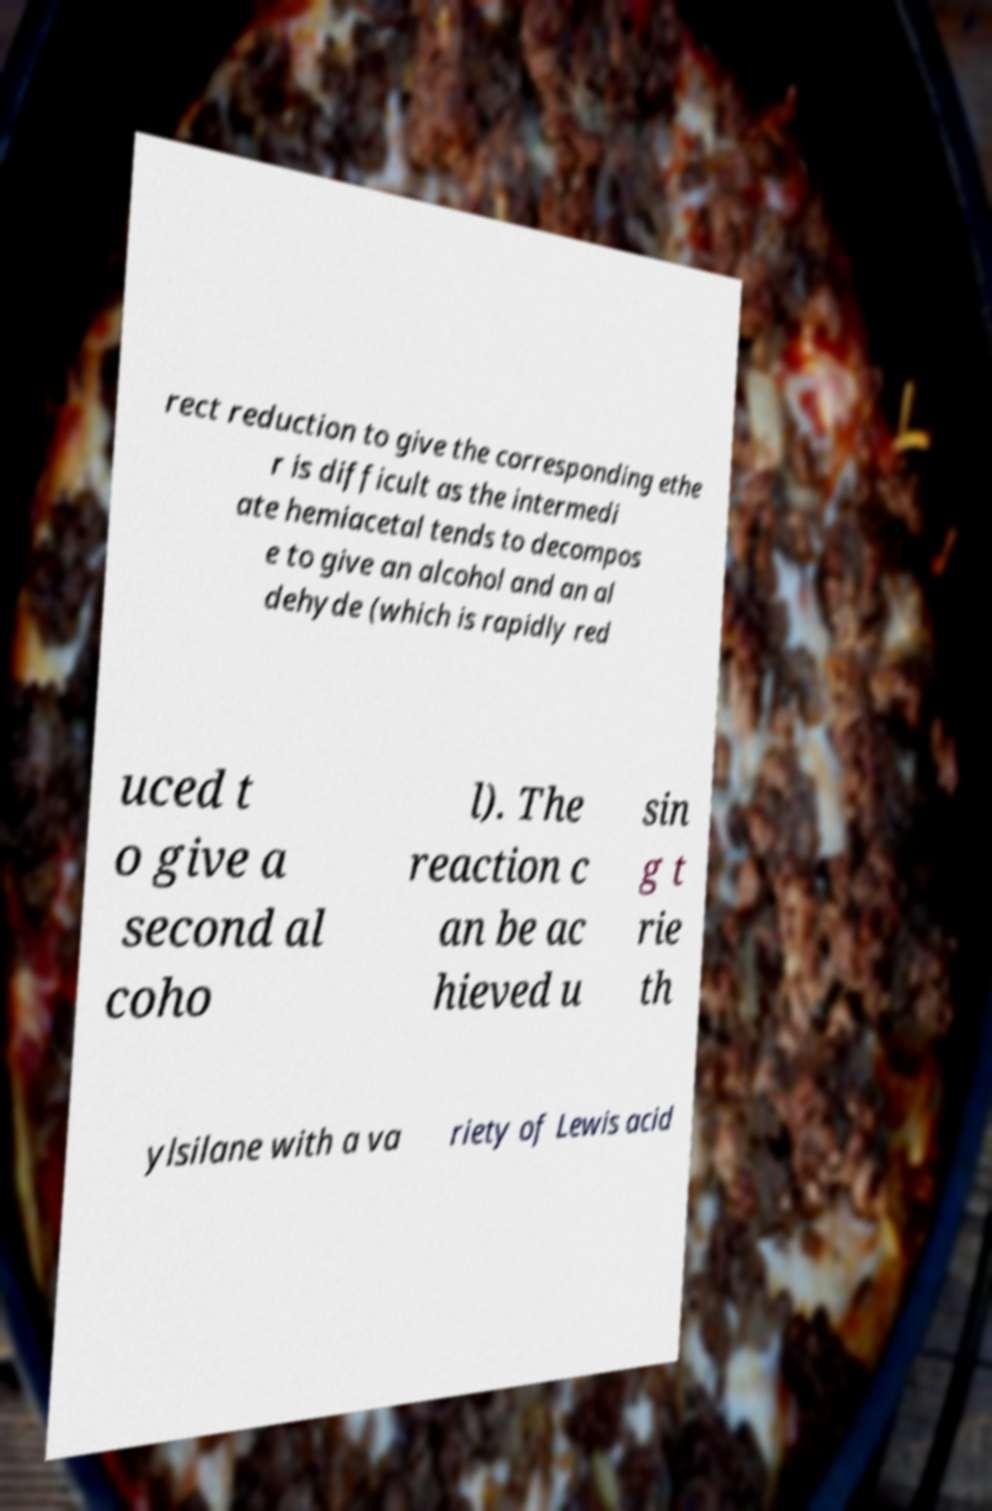Could you extract and type out the text from this image? rect reduction to give the corresponding ethe r is difficult as the intermedi ate hemiacetal tends to decompos e to give an alcohol and an al dehyde (which is rapidly red uced t o give a second al coho l). The reaction c an be ac hieved u sin g t rie th ylsilane with a va riety of Lewis acid 